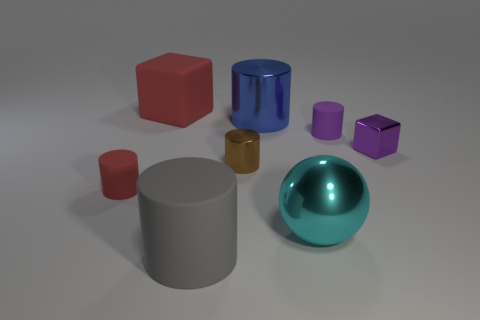Subtract all metal cylinders. How many cylinders are left? 3 Add 1 yellow metallic things. How many objects exist? 9 Subtract all purple cubes. How many cubes are left? 1 Subtract all spheres. How many objects are left? 7 Subtract all small yellow cubes. Subtract all red cylinders. How many objects are left? 7 Add 8 small red cylinders. How many small red cylinders are left? 9 Add 5 large green shiny spheres. How many large green shiny spheres exist? 5 Subtract 0 red spheres. How many objects are left? 8 Subtract all green blocks. Subtract all red cylinders. How many blocks are left? 2 